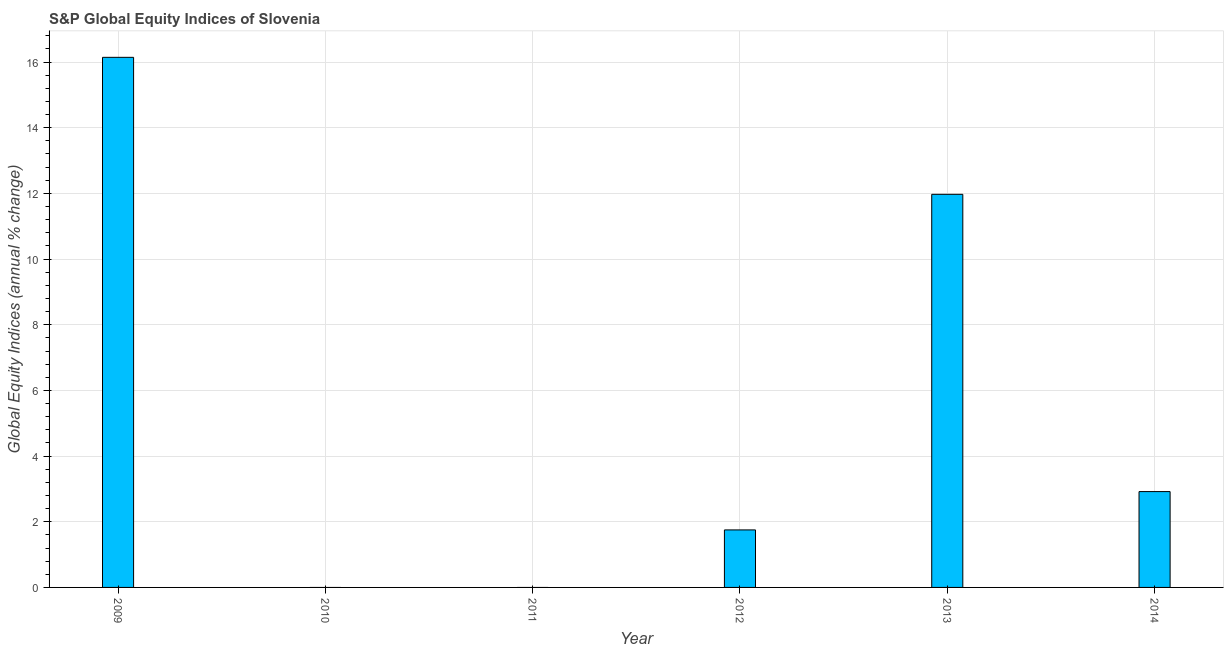Does the graph contain any zero values?
Your answer should be compact. Yes. What is the title of the graph?
Give a very brief answer. S&P Global Equity Indices of Slovenia. What is the label or title of the Y-axis?
Keep it short and to the point. Global Equity Indices (annual % change). What is the s&p global equity indices in 2010?
Your answer should be compact. 0. Across all years, what is the maximum s&p global equity indices?
Offer a terse response. 16.14. What is the sum of the s&p global equity indices?
Make the answer very short. 32.79. What is the difference between the s&p global equity indices in 2013 and 2014?
Your answer should be compact. 9.05. What is the average s&p global equity indices per year?
Offer a very short reply. 5.46. What is the median s&p global equity indices?
Provide a short and direct response. 2.34. In how many years, is the s&p global equity indices greater than 14.8 %?
Make the answer very short. 1. Is the difference between the s&p global equity indices in 2013 and 2014 greater than the difference between any two years?
Provide a short and direct response. No. What is the difference between the highest and the second highest s&p global equity indices?
Your answer should be very brief. 4.17. Is the sum of the s&p global equity indices in 2013 and 2014 greater than the maximum s&p global equity indices across all years?
Make the answer very short. No. What is the difference between the highest and the lowest s&p global equity indices?
Offer a very short reply. 16.14. Are all the bars in the graph horizontal?
Your answer should be very brief. No. How many years are there in the graph?
Your response must be concise. 6. Are the values on the major ticks of Y-axis written in scientific E-notation?
Make the answer very short. No. What is the Global Equity Indices (annual % change) in 2009?
Your answer should be very brief. 16.14. What is the Global Equity Indices (annual % change) in 2010?
Your response must be concise. 0. What is the Global Equity Indices (annual % change) in 2011?
Provide a succinct answer. 0. What is the Global Equity Indices (annual % change) of 2012?
Provide a succinct answer. 1.75. What is the Global Equity Indices (annual % change) in 2013?
Offer a terse response. 11.97. What is the Global Equity Indices (annual % change) of 2014?
Your answer should be very brief. 2.92. What is the difference between the Global Equity Indices (annual % change) in 2009 and 2012?
Keep it short and to the point. 14.39. What is the difference between the Global Equity Indices (annual % change) in 2009 and 2013?
Offer a terse response. 4.17. What is the difference between the Global Equity Indices (annual % change) in 2009 and 2014?
Provide a short and direct response. 13.22. What is the difference between the Global Equity Indices (annual % change) in 2012 and 2013?
Offer a very short reply. -10.22. What is the difference between the Global Equity Indices (annual % change) in 2012 and 2014?
Offer a terse response. -1.17. What is the difference between the Global Equity Indices (annual % change) in 2013 and 2014?
Your response must be concise. 9.05. What is the ratio of the Global Equity Indices (annual % change) in 2009 to that in 2012?
Provide a short and direct response. 9.22. What is the ratio of the Global Equity Indices (annual % change) in 2009 to that in 2013?
Your answer should be compact. 1.35. What is the ratio of the Global Equity Indices (annual % change) in 2009 to that in 2014?
Offer a very short reply. 5.53. What is the ratio of the Global Equity Indices (annual % change) in 2012 to that in 2013?
Your answer should be very brief. 0.15. What is the ratio of the Global Equity Indices (annual % change) in 2013 to that in 2014?
Your answer should be very brief. 4.1. 